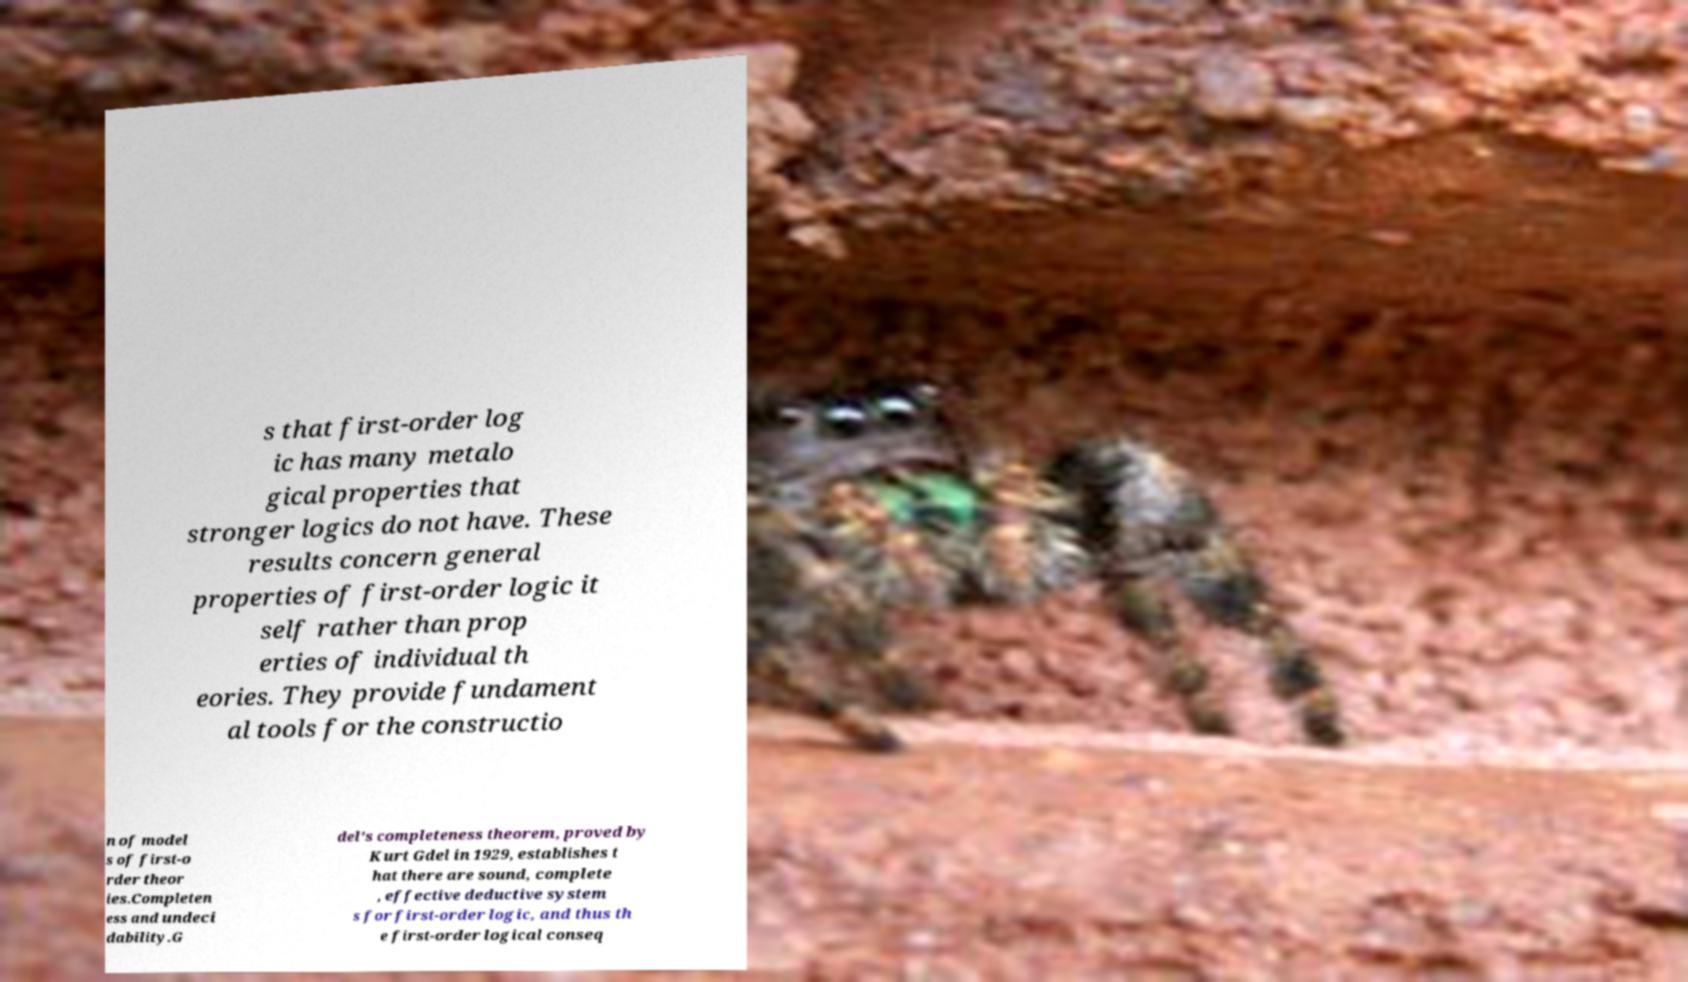Please identify and transcribe the text found in this image. s that first-order log ic has many metalo gical properties that stronger logics do not have. These results concern general properties of first-order logic it self rather than prop erties of individual th eories. They provide fundament al tools for the constructio n of model s of first-o rder theor ies.Completen ess and undeci dability.G del's completeness theorem, proved by Kurt Gdel in 1929, establishes t hat there are sound, complete , effective deductive system s for first-order logic, and thus th e first-order logical conseq 